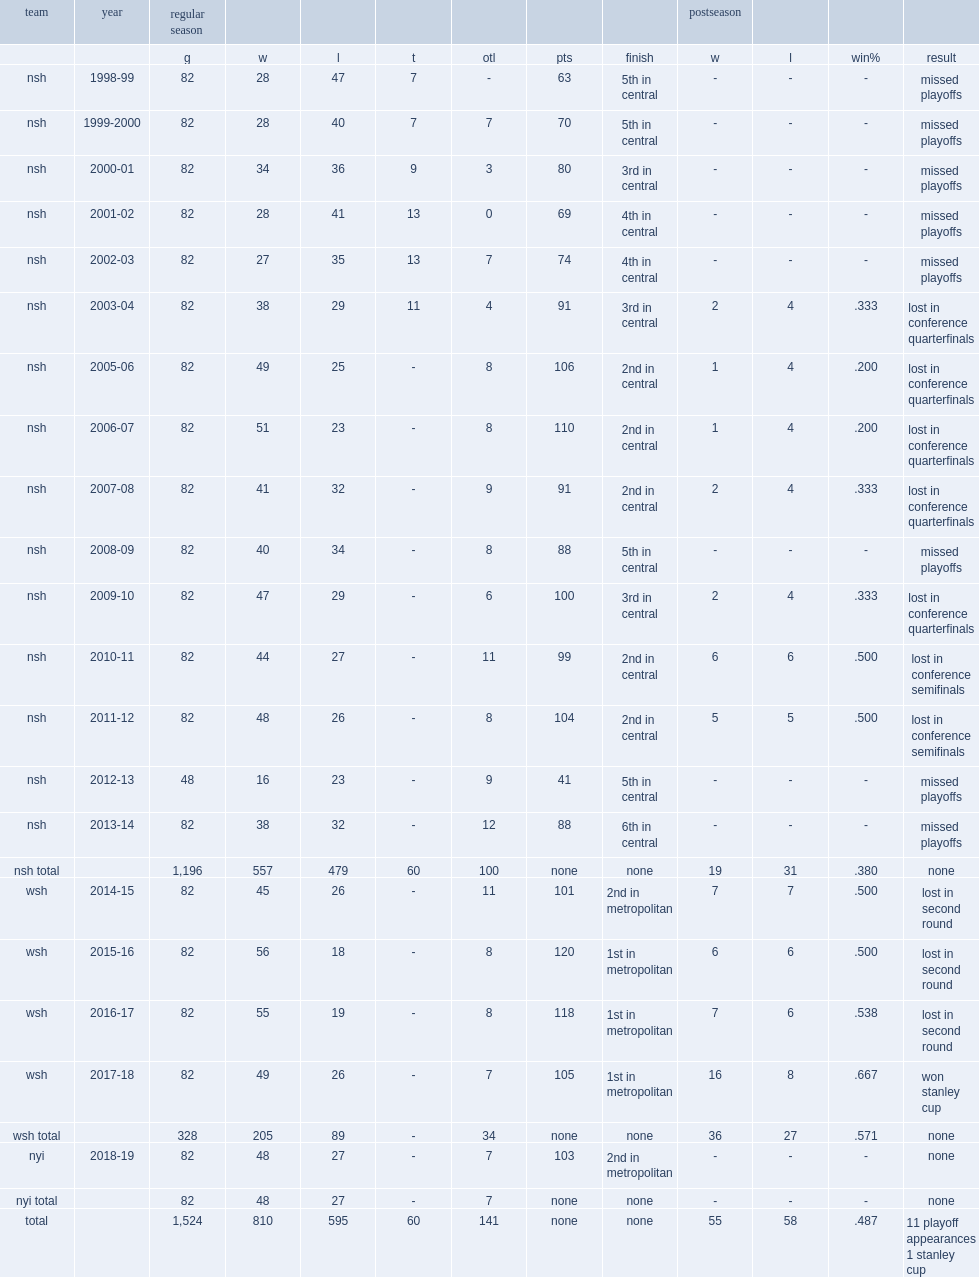How many regular season games did trotz coach totally? 1196.0. 